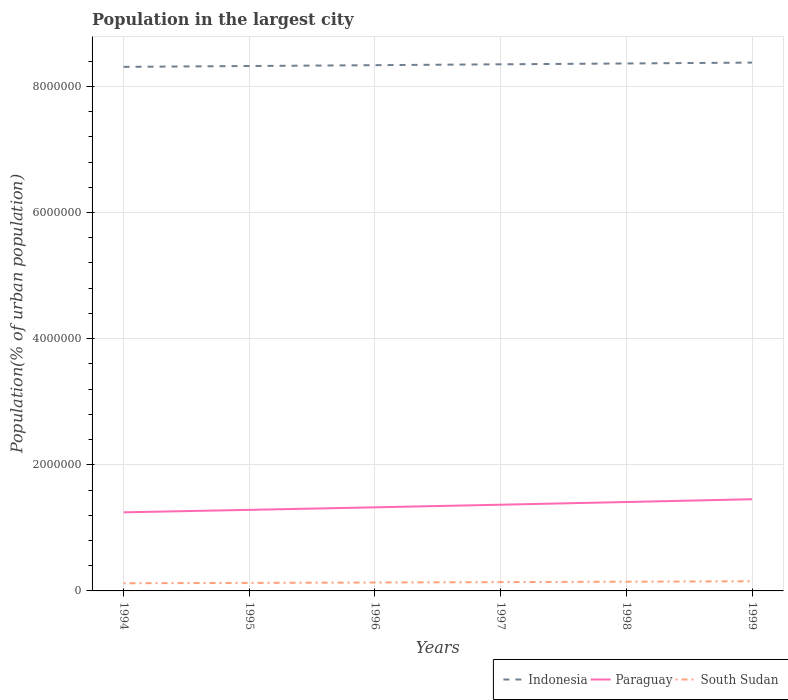Across all years, what is the maximum population in the largest city in Paraguay?
Provide a succinct answer. 1.25e+06. In which year was the population in the largest city in South Sudan maximum?
Provide a succinct answer. 1994. What is the total population in the largest city in Indonesia in the graph?
Offer a terse response. -2.69e+04. What is the difference between the highest and the second highest population in the largest city in South Sudan?
Provide a short and direct response. 3.16e+04. How many years are there in the graph?
Your answer should be very brief. 6. Are the values on the major ticks of Y-axis written in scientific E-notation?
Provide a succinct answer. No. Where does the legend appear in the graph?
Offer a terse response. Bottom right. How are the legend labels stacked?
Provide a short and direct response. Horizontal. What is the title of the graph?
Ensure brevity in your answer.  Population in the largest city. Does "Fiji" appear as one of the legend labels in the graph?
Give a very brief answer. No. What is the label or title of the X-axis?
Give a very brief answer. Years. What is the label or title of the Y-axis?
Offer a terse response. Population(% of urban population). What is the Population(% of urban population) in Indonesia in 1994?
Offer a very short reply. 8.31e+06. What is the Population(% of urban population) of Paraguay in 1994?
Give a very brief answer. 1.25e+06. What is the Population(% of urban population) in South Sudan in 1994?
Your answer should be very brief. 1.22e+05. What is the Population(% of urban population) in Indonesia in 1995?
Provide a short and direct response. 8.32e+06. What is the Population(% of urban population) of Paraguay in 1995?
Your answer should be compact. 1.29e+06. What is the Population(% of urban population) in South Sudan in 1995?
Provide a succinct answer. 1.27e+05. What is the Population(% of urban population) of Indonesia in 1996?
Provide a short and direct response. 8.34e+06. What is the Population(% of urban population) in Paraguay in 1996?
Keep it short and to the point. 1.33e+06. What is the Population(% of urban population) of South Sudan in 1996?
Your response must be concise. 1.33e+05. What is the Population(% of urban population) in Indonesia in 1997?
Make the answer very short. 8.35e+06. What is the Population(% of urban population) of Paraguay in 1997?
Provide a succinct answer. 1.37e+06. What is the Population(% of urban population) in South Sudan in 1997?
Provide a succinct answer. 1.40e+05. What is the Population(% of urban population) of Indonesia in 1998?
Provide a succinct answer. 8.36e+06. What is the Population(% of urban population) of Paraguay in 1998?
Your answer should be very brief. 1.41e+06. What is the Population(% of urban population) in South Sudan in 1998?
Offer a very short reply. 1.46e+05. What is the Population(% of urban population) of Indonesia in 1999?
Offer a terse response. 8.38e+06. What is the Population(% of urban population) of Paraguay in 1999?
Ensure brevity in your answer.  1.45e+06. What is the Population(% of urban population) in South Sudan in 1999?
Give a very brief answer. 1.53e+05. Across all years, what is the maximum Population(% of urban population) of Indonesia?
Your response must be concise. 8.38e+06. Across all years, what is the maximum Population(% of urban population) in Paraguay?
Your answer should be very brief. 1.45e+06. Across all years, what is the maximum Population(% of urban population) in South Sudan?
Provide a succinct answer. 1.53e+05. Across all years, what is the minimum Population(% of urban population) in Indonesia?
Your response must be concise. 8.31e+06. Across all years, what is the minimum Population(% of urban population) in Paraguay?
Offer a very short reply. 1.25e+06. Across all years, what is the minimum Population(% of urban population) of South Sudan?
Make the answer very short. 1.22e+05. What is the total Population(% of urban population) of Indonesia in the graph?
Ensure brevity in your answer.  5.01e+07. What is the total Population(% of urban population) of Paraguay in the graph?
Provide a short and direct response. 8.09e+06. What is the total Population(% of urban population) of South Sudan in the graph?
Offer a very short reply. 8.22e+05. What is the difference between the Population(% of urban population) of Indonesia in 1994 and that in 1995?
Your response must be concise. -1.35e+04. What is the difference between the Population(% of urban population) in Paraguay in 1994 and that in 1995?
Offer a very short reply. -3.90e+04. What is the difference between the Population(% of urban population) of South Sudan in 1994 and that in 1995?
Make the answer very short. -5751. What is the difference between the Population(% of urban population) in Indonesia in 1994 and that in 1996?
Make the answer very short. -2.69e+04. What is the difference between the Population(% of urban population) in Paraguay in 1994 and that in 1996?
Offer a very short reply. -7.92e+04. What is the difference between the Population(% of urban population) of South Sudan in 1994 and that in 1996?
Make the answer very short. -1.18e+04. What is the difference between the Population(% of urban population) in Indonesia in 1994 and that in 1997?
Provide a succinct answer. -4.04e+04. What is the difference between the Population(% of urban population) of Paraguay in 1994 and that in 1997?
Provide a succinct answer. -1.21e+05. What is the difference between the Population(% of urban population) of South Sudan in 1994 and that in 1997?
Your response must be concise. -1.81e+04. What is the difference between the Population(% of urban population) of Indonesia in 1994 and that in 1998?
Provide a succinct answer. -5.39e+04. What is the difference between the Population(% of urban population) in Paraguay in 1994 and that in 1998?
Provide a succinct answer. -1.63e+05. What is the difference between the Population(% of urban population) in South Sudan in 1994 and that in 1998?
Your response must be concise. -2.47e+04. What is the difference between the Population(% of urban population) of Indonesia in 1994 and that in 1999?
Offer a very short reply. -6.75e+04. What is the difference between the Population(% of urban population) in Paraguay in 1994 and that in 1999?
Offer a very short reply. -2.07e+05. What is the difference between the Population(% of urban population) of South Sudan in 1994 and that in 1999?
Offer a terse response. -3.16e+04. What is the difference between the Population(% of urban population) of Indonesia in 1995 and that in 1996?
Your response must be concise. -1.35e+04. What is the difference between the Population(% of urban population) of Paraguay in 1995 and that in 1996?
Your answer should be compact. -4.02e+04. What is the difference between the Population(% of urban population) of South Sudan in 1995 and that in 1996?
Your response must be concise. -6032. What is the difference between the Population(% of urban population) in Indonesia in 1995 and that in 1997?
Give a very brief answer. -2.70e+04. What is the difference between the Population(% of urban population) of Paraguay in 1995 and that in 1997?
Ensure brevity in your answer.  -8.16e+04. What is the difference between the Population(% of urban population) of South Sudan in 1995 and that in 1997?
Your response must be concise. -1.23e+04. What is the difference between the Population(% of urban population) of Indonesia in 1995 and that in 1998?
Ensure brevity in your answer.  -4.05e+04. What is the difference between the Population(% of urban population) in Paraguay in 1995 and that in 1998?
Ensure brevity in your answer.  -1.24e+05. What is the difference between the Population(% of urban population) of South Sudan in 1995 and that in 1998?
Ensure brevity in your answer.  -1.89e+04. What is the difference between the Population(% of urban population) of Indonesia in 1995 and that in 1999?
Your answer should be compact. -5.40e+04. What is the difference between the Population(% of urban population) of Paraguay in 1995 and that in 1999?
Keep it short and to the point. -1.68e+05. What is the difference between the Population(% of urban population) of South Sudan in 1995 and that in 1999?
Offer a very short reply. -2.59e+04. What is the difference between the Population(% of urban population) of Indonesia in 1996 and that in 1997?
Keep it short and to the point. -1.35e+04. What is the difference between the Population(% of urban population) of Paraguay in 1996 and that in 1997?
Your answer should be compact. -4.14e+04. What is the difference between the Population(% of urban population) of South Sudan in 1996 and that in 1997?
Your answer should be compact. -6300. What is the difference between the Population(% of urban population) of Indonesia in 1996 and that in 1998?
Ensure brevity in your answer.  -2.70e+04. What is the difference between the Population(% of urban population) in Paraguay in 1996 and that in 1998?
Offer a very short reply. -8.41e+04. What is the difference between the Population(% of urban population) of South Sudan in 1996 and that in 1998?
Give a very brief answer. -1.29e+04. What is the difference between the Population(% of urban population) of Indonesia in 1996 and that in 1999?
Provide a short and direct response. -4.05e+04. What is the difference between the Population(% of urban population) of Paraguay in 1996 and that in 1999?
Your answer should be compact. -1.28e+05. What is the difference between the Population(% of urban population) of South Sudan in 1996 and that in 1999?
Offer a very short reply. -1.98e+04. What is the difference between the Population(% of urban population) in Indonesia in 1997 and that in 1998?
Provide a succinct answer. -1.35e+04. What is the difference between the Population(% of urban population) in Paraguay in 1997 and that in 1998?
Your answer should be compact. -4.27e+04. What is the difference between the Population(% of urban population) in South Sudan in 1997 and that in 1998?
Offer a terse response. -6606. What is the difference between the Population(% of urban population) of Indonesia in 1997 and that in 1999?
Offer a very short reply. -2.71e+04. What is the difference between the Population(% of urban population) of Paraguay in 1997 and that in 1999?
Ensure brevity in your answer.  -8.68e+04. What is the difference between the Population(% of urban population) in South Sudan in 1997 and that in 1999?
Ensure brevity in your answer.  -1.35e+04. What is the difference between the Population(% of urban population) in Indonesia in 1998 and that in 1999?
Make the answer very short. -1.35e+04. What is the difference between the Population(% of urban population) of Paraguay in 1998 and that in 1999?
Provide a short and direct response. -4.41e+04. What is the difference between the Population(% of urban population) in South Sudan in 1998 and that in 1999?
Offer a very short reply. -6919. What is the difference between the Population(% of urban population) of Indonesia in 1994 and the Population(% of urban population) of Paraguay in 1995?
Offer a very short reply. 7.02e+06. What is the difference between the Population(% of urban population) in Indonesia in 1994 and the Population(% of urban population) in South Sudan in 1995?
Offer a terse response. 8.18e+06. What is the difference between the Population(% of urban population) of Paraguay in 1994 and the Population(% of urban population) of South Sudan in 1995?
Keep it short and to the point. 1.12e+06. What is the difference between the Population(% of urban population) in Indonesia in 1994 and the Population(% of urban population) in Paraguay in 1996?
Make the answer very short. 6.98e+06. What is the difference between the Population(% of urban population) of Indonesia in 1994 and the Population(% of urban population) of South Sudan in 1996?
Ensure brevity in your answer.  8.18e+06. What is the difference between the Population(% of urban population) in Paraguay in 1994 and the Population(% of urban population) in South Sudan in 1996?
Offer a terse response. 1.11e+06. What is the difference between the Population(% of urban population) in Indonesia in 1994 and the Population(% of urban population) in Paraguay in 1997?
Your answer should be very brief. 6.94e+06. What is the difference between the Population(% of urban population) in Indonesia in 1994 and the Population(% of urban population) in South Sudan in 1997?
Your response must be concise. 8.17e+06. What is the difference between the Population(% of urban population) of Paraguay in 1994 and the Population(% of urban population) of South Sudan in 1997?
Offer a very short reply. 1.11e+06. What is the difference between the Population(% of urban population) of Indonesia in 1994 and the Population(% of urban population) of Paraguay in 1998?
Offer a very short reply. 6.90e+06. What is the difference between the Population(% of urban population) in Indonesia in 1994 and the Population(% of urban population) in South Sudan in 1998?
Offer a terse response. 8.16e+06. What is the difference between the Population(% of urban population) of Paraguay in 1994 and the Population(% of urban population) of South Sudan in 1998?
Keep it short and to the point. 1.10e+06. What is the difference between the Population(% of urban population) in Indonesia in 1994 and the Population(% of urban population) in Paraguay in 1999?
Keep it short and to the point. 6.85e+06. What is the difference between the Population(% of urban population) of Indonesia in 1994 and the Population(% of urban population) of South Sudan in 1999?
Provide a short and direct response. 8.16e+06. What is the difference between the Population(% of urban population) of Paraguay in 1994 and the Population(% of urban population) of South Sudan in 1999?
Ensure brevity in your answer.  1.09e+06. What is the difference between the Population(% of urban population) of Indonesia in 1995 and the Population(% of urban population) of Paraguay in 1996?
Keep it short and to the point. 7.00e+06. What is the difference between the Population(% of urban population) of Indonesia in 1995 and the Population(% of urban population) of South Sudan in 1996?
Keep it short and to the point. 8.19e+06. What is the difference between the Population(% of urban population) in Paraguay in 1995 and the Population(% of urban population) in South Sudan in 1996?
Your answer should be compact. 1.15e+06. What is the difference between the Population(% of urban population) in Indonesia in 1995 and the Population(% of urban population) in Paraguay in 1997?
Offer a very short reply. 6.96e+06. What is the difference between the Population(% of urban population) of Indonesia in 1995 and the Population(% of urban population) of South Sudan in 1997?
Provide a succinct answer. 8.18e+06. What is the difference between the Population(% of urban population) in Paraguay in 1995 and the Population(% of urban population) in South Sudan in 1997?
Offer a terse response. 1.15e+06. What is the difference between the Population(% of urban population) in Indonesia in 1995 and the Population(% of urban population) in Paraguay in 1998?
Make the answer very short. 6.91e+06. What is the difference between the Population(% of urban population) of Indonesia in 1995 and the Population(% of urban population) of South Sudan in 1998?
Your response must be concise. 8.18e+06. What is the difference between the Population(% of urban population) of Paraguay in 1995 and the Population(% of urban population) of South Sudan in 1998?
Offer a very short reply. 1.14e+06. What is the difference between the Population(% of urban population) in Indonesia in 1995 and the Population(% of urban population) in Paraguay in 1999?
Make the answer very short. 6.87e+06. What is the difference between the Population(% of urban population) of Indonesia in 1995 and the Population(% of urban population) of South Sudan in 1999?
Give a very brief answer. 8.17e+06. What is the difference between the Population(% of urban population) of Paraguay in 1995 and the Population(% of urban population) of South Sudan in 1999?
Make the answer very short. 1.13e+06. What is the difference between the Population(% of urban population) in Indonesia in 1996 and the Population(% of urban population) in Paraguay in 1997?
Your response must be concise. 6.97e+06. What is the difference between the Population(% of urban population) in Indonesia in 1996 and the Population(% of urban population) in South Sudan in 1997?
Give a very brief answer. 8.20e+06. What is the difference between the Population(% of urban population) of Paraguay in 1996 and the Population(% of urban population) of South Sudan in 1997?
Give a very brief answer. 1.19e+06. What is the difference between the Population(% of urban population) of Indonesia in 1996 and the Population(% of urban population) of Paraguay in 1998?
Offer a terse response. 6.93e+06. What is the difference between the Population(% of urban population) in Indonesia in 1996 and the Population(% of urban population) in South Sudan in 1998?
Ensure brevity in your answer.  8.19e+06. What is the difference between the Population(% of urban population) in Paraguay in 1996 and the Population(% of urban population) in South Sudan in 1998?
Give a very brief answer. 1.18e+06. What is the difference between the Population(% of urban population) of Indonesia in 1996 and the Population(% of urban population) of Paraguay in 1999?
Your answer should be very brief. 6.88e+06. What is the difference between the Population(% of urban population) of Indonesia in 1996 and the Population(% of urban population) of South Sudan in 1999?
Keep it short and to the point. 8.18e+06. What is the difference between the Population(% of urban population) in Paraguay in 1996 and the Population(% of urban population) in South Sudan in 1999?
Offer a terse response. 1.17e+06. What is the difference between the Population(% of urban population) in Indonesia in 1997 and the Population(% of urban population) in Paraguay in 1998?
Give a very brief answer. 6.94e+06. What is the difference between the Population(% of urban population) in Indonesia in 1997 and the Population(% of urban population) in South Sudan in 1998?
Offer a terse response. 8.20e+06. What is the difference between the Population(% of urban population) in Paraguay in 1997 and the Population(% of urban population) in South Sudan in 1998?
Your answer should be very brief. 1.22e+06. What is the difference between the Population(% of urban population) of Indonesia in 1997 and the Population(% of urban population) of Paraguay in 1999?
Ensure brevity in your answer.  6.90e+06. What is the difference between the Population(% of urban population) of Indonesia in 1997 and the Population(% of urban population) of South Sudan in 1999?
Keep it short and to the point. 8.20e+06. What is the difference between the Population(% of urban population) in Paraguay in 1997 and the Population(% of urban population) in South Sudan in 1999?
Ensure brevity in your answer.  1.21e+06. What is the difference between the Population(% of urban population) in Indonesia in 1998 and the Population(% of urban population) in Paraguay in 1999?
Your answer should be compact. 6.91e+06. What is the difference between the Population(% of urban population) in Indonesia in 1998 and the Population(% of urban population) in South Sudan in 1999?
Ensure brevity in your answer.  8.21e+06. What is the difference between the Population(% of urban population) of Paraguay in 1998 and the Population(% of urban population) of South Sudan in 1999?
Provide a succinct answer. 1.26e+06. What is the average Population(% of urban population) of Indonesia per year?
Provide a short and direct response. 8.34e+06. What is the average Population(% of urban population) of Paraguay per year?
Provide a short and direct response. 1.35e+06. What is the average Population(% of urban population) in South Sudan per year?
Make the answer very short. 1.37e+05. In the year 1994, what is the difference between the Population(% of urban population) in Indonesia and Population(% of urban population) in Paraguay?
Your answer should be very brief. 7.06e+06. In the year 1994, what is the difference between the Population(% of urban population) of Indonesia and Population(% of urban population) of South Sudan?
Make the answer very short. 8.19e+06. In the year 1994, what is the difference between the Population(% of urban population) in Paraguay and Population(% of urban population) in South Sudan?
Provide a succinct answer. 1.12e+06. In the year 1995, what is the difference between the Population(% of urban population) of Indonesia and Population(% of urban population) of Paraguay?
Your response must be concise. 7.04e+06. In the year 1995, what is the difference between the Population(% of urban population) of Indonesia and Population(% of urban population) of South Sudan?
Keep it short and to the point. 8.19e+06. In the year 1995, what is the difference between the Population(% of urban population) in Paraguay and Population(% of urban population) in South Sudan?
Keep it short and to the point. 1.16e+06. In the year 1996, what is the difference between the Population(% of urban population) in Indonesia and Population(% of urban population) in Paraguay?
Your answer should be very brief. 7.01e+06. In the year 1996, what is the difference between the Population(% of urban population) of Indonesia and Population(% of urban population) of South Sudan?
Provide a succinct answer. 8.20e+06. In the year 1996, what is the difference between the Population(% of urban population) of Paraguay and Population(% of urban population) of South Sudan?
Your response must be concise. 1.19e+06. In the year 1997, what is the difference between the Population(% of urban population) of Indonesia and Population(% of urban population) of Paraguay?
Your answer should be compact. 6.98e+06. In the year 1997, what is the difference between the Population(% of urban population) of Indonesia and Population(% of urban population) of South Sudan?
Make the answer very short. 8.21e+06. In the year 1997, what is the difference between the Population(% of urban population) in Paraguay and Population(% of urban population) in South Sudan?
Make the answer very short. 1.23e+06. In the year 1998, what is the difference between the Population(% of urban population) in Indonesia and Population(% of urban population) in Paraguay?
Ensure brevity in your answer.  6.95e+06. In the year 1998, what is the difference between the Population(% of urban population) of Indonesia and Population(% of urban population) of South Sudan?
Provide a succinct answer. 8.22e+06. In the year 1998, what is the difference between the Population(% of urban population) in Paraguay and Population(% of urban population) in South Sudan?
Offer a terse response. 1.26e+06. In the year 1999, what is the difference between the Population(% of urban population) of Indonesia and Population(% of urban population) of Paraguay?
Your response must be concise. 6.92e+06. In the year 1999, what is the difference between the Population(% of urban population) of Indonesia and Population(% of urban population) of South Sudan?
Keep it short and to the point. 8.22e+06. In the year 1999, what is the difference between the Population(% of urban population) of Paraguay and Population(% of urban population) of South Sudan?
Your answer should be very brief. 1.30e+06. What is the ratio of the Population(% of urban population) in Paraguay in 1994 to that in 1995?
Provide a succinct answer. 0.97. What is the ratio of the Population(% of urban population) of South Sudan in 1994 to that in 1995?
Keep it short and to the point. 0.95. What is the ratio of the Population(% of urban population) in Paraguay in 1994 to that in 1996?
Your response must be concise. 0.94. What is the ratio of the Population(% of urban population) of South Sudan in 1994 to that in 1996?
Your response must be concise. 0.91. What is the ratio of the Population(% of urban population) of Indonesia in 1994 to that in 1997?
Keep it short and to the point. 1. What is the ratio of the Population(% of urban population) of Paraguay in 1994 to that in 1997?
Offer a terse response. 0.91. What is the ratio of the Population(% of urban population) in South Sudan in 1994 to that in 1997?
Your answer should be very brief. 0.87. What is the ratio of the Population(% of urban population) of Indonesia in 1994 to that in 1998?
Your answer should be compact. 0.99. What is the ratio of the Population(% of urban population) of Paraguay in 1994 to that in 1998?
Give a very brief answer. 0.88. What is the ratio of the Population(% of urban population) of South Sudan in 1994 to that in 1998?
Provide a succinct answer. 0.83. What is the ratio of the Population(% of urban population) in Paraguay in 1994 to that in 1999?
Your answer should be very brief. 0.86. What is the ratio of the Population(% of urban population) of South Sudan in 1994 to that in 1999?
Offer a terse response. 0.79. What is the ratio of the Population(% of urban population) of Paraguay in 1995 to that in 1996?
Provide a short and direct response. 0.97. What is the ratio of the Population(% of urban population) in South Sudan in 1995 to that in 1996?
Offer a terse response. 0.95. What is the ratio of the Population(% of urban population) in Paraguay in 1995 to that in 1997?
Keep it short and to the point. 0.94. What is the ratio of the Population(% of urban population) of South Sudan in 1995 to that in 1997?
Keep it short and to the point. 0.91. What is the ratio of the Population(% of urban population) in Paraguay in 1995 to that in 1998?
Your response must be concise. 0.91. What is the ratio of the Population(% of urban population) of South Sudan in 1995 to that in 1998?
Offer a terse response. 0.87. What is the ratio of the Population(% of urban population) of Indonesia in 1995 to that in 1999?
Ensure brevity in your answer.  0.99. What is the ratio of the Population(% of urban population) of Paraguay in 1995 to that in 1999?
Keep it short and to the point. 0.88. What is the ratio of the Population(% of urban population) in South Sudan in 1995 to that in 1999?
Offer a terse response. 0.83. What is the ratio of the Population(% of urban population) of Indonesia in 1996 to that in 1997?
Your response must be concise. 1. What is the ratio of the Population(% of urban population) in Paraguay in 1996 to that in 1997?
Your response must be concise. 0.97. What is the ratio of the Population(% of urban population) in South Sudan in 1996 to that in 1997?
Give a very brief answer. 0.95. What is the ratio of the Population(% of urban population) of Paraguay in 1996 to that in 1998?
Your answer should be very brief. 0.94. What is the ratio of the Population(% of urban population) of South Sudan in 1996 to that in 1998?
Your answer should be very brief. 0.91. What is the ratio of the Population(% of urban population) of Indonesia in 1996 to that in 1999?
Keep it short and to the point. 1. What is the ratio of the Population(% of urban population) of Paraguay in 1996 to that in 1999?
Give a very brief answer. 0.91. What is the ratio of the Population(% of urban population) in South Sudan in 1996 to that in 1999?
Provide a short and direct response. 0.87. What is the ratio of the Population(% of urban population) of Indonesia in 1997 to that in 1998?
Your response must be concise. 1. What is the ratio of the Population(% of urban population) in Paraguay in 1997 to that in 1998?
Provide a succinct answer. 0.97. What is the ratio of the Population(% of urban population) in South Sudan in 1997 to that in 1998?
Provide a short and direct response. 0.95. What is the ratio of the Population(% of urban population) in Indonesia in 1997 to that in 1999?
Offer a very short reply. 1. What is the ratio of the Population(% of urban population) of Paraguay in 1997 to that in 1999?
Ensure brevity in your answer.  0.94. What is the ratio of the Population(% of urban population) of South Sudan in 1997 to that in 1999?
Provide a succinct answer. 0.91. What is the ratio of the Population(% of urban population) of Indonesia in 1998 to that in 1999?
Your answer should be very brief. 1. What is the ratio of the Population(% of urban population) of Paraguay in 1998 to that in 1999?
Your answer should be very brief. 0.97. What is the ratio of the Population(% of urban population) of South Sudan in 1998 to that in 1999?
Keep it short and to the point. 0.95. What is the difference between the highest and the second highest Population(% of urban population) of Indonesia?
Offer a terse response. 1.35e+04. What is the difference between the highest and the second highest Population(% of urban population) in Paraguay?
Offer a very short reply. 4.41e+04. What is the difference between the highest and the second highest Population(% of urban population) of South Sudan?
Your answer should be very brief. 6919. What is the difference between the highest and the lowest Population(% of urban population) of Indonesia?
Provide a short and direct response. 6.75e+04. What is the difference between the highest and the lowest Population(% of urban population) of Paraguay?
Make the answer very short. 2.07e+05. What is the difference between the highest and the lowest Population(% of urban population) of South Sudan?
Make the answer very short. 3.16e+04. 